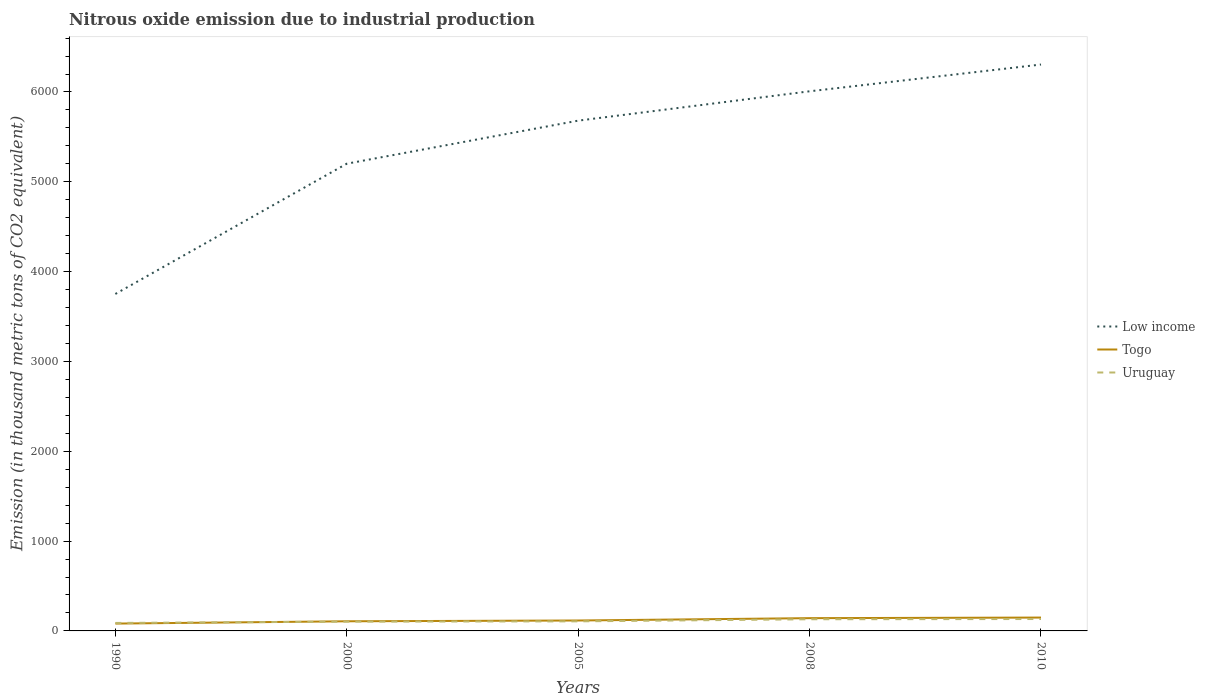How many different coloured lines are there?
Offer a terse response. 3. Across all years, what is the maximum amount of nitrous oxide emitted in Uruguay?
Offer a very short reply. 88.8. What is the total amount of nitrous oxide emitted in Low income in the graph?
Make the answer very short. -1929.5. What is the difference between the highest and the second highest amount of nitrous oxide emitted in Uruguay?
Your response must be concise. 43.7. Is the amount of nitrous oxide emitted in Togo strictly greater than the amount of nitrous oxide emitted in Uruguay over the years?
Give a very brief answer. No. How many lines are there?
Offer a terse response. 3. What is the difference between two consecutive major ticks on the Y-axis?
Provide a short and direct response. 1000. Does the graph contain any zero values?
Give a very brief answer. No. How many legend labels are there?
Give a very brief answer. 3. What is the title of the graph?
Provide a succinct answer. Nitrous oxide emission due to industrial production. Does "Comoros" appear as one of the legend labels in the graph?
Provide a short and direct response. No. What is the label or title of the X-axis?
Give a very brief answer. Years. What is the label or title of the Y-axis?
Your answer should be very brief. Emission (in thousand metric tons of CO2 equivalent). What is the Emission (in thousand metric tons of CO2 equivalent) of Low income in 1990?
Offer a terse response. 3751.3. What is the Emission (in thousand metric tons of CO2 equivalent) of Togo in 1990?
Your answer should be compact. 81.8. What is the Emission (in thousand metric tons of CO2 equivalent) in Uruguay in 1990?
Make the answer very short. 88.8. What is the Emission (in thousand metric tons of CO2 equivalent) of Low income in 2000?
Keep it short and to the point. 5201.5. What is the Emission (in thousand metric tons of CO2 equivalent) of Togo in 2000?
Ensure brevity in your answer.  107.3. What is the Emission (in thousand metric tons of CO2 equivalent) in Uruguay in 2000?
Provide a succinct answer. 103.4. What is the Emission (in thousand metric tons of CO2 equivalent) in Low income in 2005?
Offer a very short reply. 5680.8. What is the Emission (in thousand metric tons of CO2 equivalent) of Togo in 2005?
Provide a short and direct response. 116. What is the Emission (in thousand metric tons of CO2 equivalent) of Uruguay in 2005?
Provide a short and direct response. 106.6. What is the Emission (in thousand metric tons of CO2 equivalent) of Low income in 2008?
Offer a very short reply. 6007.5. What is the Emission (in thousand metric tons of CO2 equivalent) in Togo in 2008?
Your answer should be very brief. 142.1. What is the Emission (in thousand metric tons of CO2 equivalent) in Uruguay in 2008?
Offer a very short reply. 129.9. What is the Emission (in thousand metric tons of CO2 equivalent) of Low income in 2010?
Make the answer very short. 6305.5. What is the Emission (in thousand metric tons of CO2 equivalent) of Togo in 2010?
Make the answer very short. 148.8. What is the Emission (in thousand metric tons of CO2 equivalent) in Uruguay in 2010?
Make the answer very short. 132.5. Across all years, what is the maximum Emission (in thousand metric tons of CO2 equivalent) in Low income?
Ensure brevity in your answer.  6305.5. Across all years, what is the maximum Emission (in thousand metric tons of CO2 equivalent) in Togo?
Give a very brief answer. 148.8. Across all years, what is the maximum Emission (in thousand metric tons of CO2 equivalent) in Uruguay?
Ensure brevity in your answer.  132.5. Across all years, what is the minimum Emission (in thousand metric tons of CO2 equivalent) of Low income?
Provide a short and direct response. 3751.3. Across all years, what is the minimum Emission (in thousand metric tons of CO2 equivalent) in Togo?
Keep it short and to the point. 81.8. Across all years, what is the minimum Emission (in thousand metric tons of CO2 equivalent) of Uruguay?
Make the answer very short. 88.8. What is the total Emission (in thousand metric tons of CO2 equivalent) of Low income in the graph?
Your response must be concise. 2.69e+04. What is the total Emission (in thousand metric tons of CO2 equivalent) of Togo in the graph?
Make the answer very short. 596. What is the total Emission (in thousand metric tons of CO2 equivalent) in Uruguay in the graph?
Keep it short and to the point. 561.2. What is the difference between the Emission (in thousand metric tons of CO2 equivalent) of Low income in 1990 and that in 2000?
Your answer should be compact. -1450.2. What is the difference between the Emission (in thousand metric tons of CO2 equivalent) in Togo in 1990 and that in 2000?
Ensure brevity in your answer.  -25.5. What is the difference between the Emission (in thousand metric tons of CO2 equivalent) of Uruguay in 1990 and that in 2000?
Offer a very short reply. -14.6. What is the difference between the Emission (in thousand metric tons of CO2 equivalent) of Low income in 1990 and that in 2005?
Offer a very short reply. -1929.5. What is the difference between the Emission (in thousand metric tons of CO2 equivalent) of Togo in 1990 and that in 2005?
Your answer should be very brief. -34.2. What is the difference between the Emission (in thousand metric tons of CO2 equivalent) of Uruguay in 1990 and that in 2005?
Your answer should be very brief. -17.8. What is the difference between the Emission (in thousand metric tons of CO2 equivalent) of Low income in 1990 and that in 2008?
Provide a succinct answer. -2256.2. What is the difference between the Emission (in thousand metric tons of CO2 equivalent) of Togo in 1990 and that in 2008?
Ensure brevity in your answer.  -60.3. What is the difference between the Emission (in thousand metric tons of CO2 equivalent) of Uruguay in 1990 and that in 2008?
Your response must be concise. -41.1. What is the difference between the Emission (in thousand metric tons of CO2 equivalent) of Low income in 1990 and that in 2010?
Offer a terse response. -2554.2. What is the difference between the Emission (in thousand metric tons of CO2 equivalent) of Togo in 1990 and that in 2010?
Your response must be concise. -67. What is the difference between the Emission (in thousand metric tons of CO2 equivalent) in Uruguay in 1990 and that in 2010?
Provide a succinct answer. -43.7. What is the difference between the Emission (in thousand metric tons of CO2 equivalent) in Low income in 2000 and that in 2005?
Keep it short and to the point. -479.3. What is the difference between the Emission (in thousand metric tons of CO2 equivalent) in Uruguay in 2000 and that in 2005?
Offer a very short reply. -3.2. What is the difference between the Emission (in thousand metric tons of CO2 equivalent) of Low income in 2000 and that in 2008?
Make the answer very short. -806. What is the difference between the Emission (in thousand metric tons of CO2 equivalent) of Togo in 2000 and that in 2008?
Offer a terse response. -34.8. What is the difference between the Emission (in thousand metric tons of CO2 equivalent) in Uruguay in 2000 and that in 2008?
Make the answer very short. -26.5. What is the difference between the Emission (in thousand metric tons of CO2 equivalent) of Low income in 2000 and that in 2010?
Your answer should be compact. -1104. What is the difference between the Emission (in thousand metric tons of CO2 equivalent) of Togo in 2000 and that in 2010?
Provide a short and direct response. -41.5. What is the difference between the Emission (in thousand metric tons of CO2 equivalent) in Uruguay in 2000 and that in 2010?
Offer a very short reply. -29.1. What is the difference between the Emission (in thousand metric tons of CO2 equivalent) of Low income in 2005 and that in 2008?
Make the answer very short. -326.7. What is the difference between the Emission (in thousand metric tons of CO2 equivalent) in Togo in 2005 and that in 2008?
Your response must be concise. -26.1. What is the difference between the Emission (in thousand metric tons of CO2 equivalent) of Uruguay in 2005 and that in 2008?
Your answer should be very brief. -23.3. What is the difference between the Emission (in thousand metric tons of CO2 equivalent) of Low income in 2005 and that in 2010?
Provide a short and direct response. -624.7. What is the difference between the Emission (in thousand metric tons of CO2 equivalent) of Togo in 2005 and that in 2010?
Your answer should be very brief. -32.8. What is the difference between the Emission (in thousand metric tons of CO2 equivalent) of Uruguay in 2005 and that in 2010?
Your answer should be very brief. -25.9. What is the difference between the Emission (in thousand metric tons of CO2 equivalent) in Low income in 2008 and that in 2010?
Your answer should be very brief. -298. What is the difference between the Emission (in thousand metric tons of CO2 equivalent) of Togo in 2008 and that in 2010?
Your answer should be compact. -6.7. What is the difference between the Emission (in thousand metric tons of CO2 equivalent) in Low income in 1990 and the Emission (in thousand metric tons of CO2 equivalent) in Togo in 2000?
Give a very brief answer. 3644. What is the difference between the Emission (in thousand metric tons of CO2 equivalent) of Low income in 1990 and the Emission (in thousand metric tons of CO2 equivalent) of Uruguay in 2000?
Ensure brevity in your answer.  3647.9. What is the difference between the Emission (in thousand metric tons of CO2 equivalent) in Togo in 1990 and the Emission (in thousand metric tons of CO2 equivalent) in Uruguay in 2000?
Make the answer very short. -21.6. What is the difference between the Emission (in thousand metric tons of CO2 equivalent) of Low income in 1990 and the Emission (in thousand metric tons of CO2 equivalent) of Togo in 2005?
Keep it short and to the point. 3635.3. What is the difference between the Emission (in thousand metric tons of CO2 equivalent) in Low income in 1990 and the Emission (in thousand metric tons of CO2 equivalent) in Uruguay in 2005?
Offer a very short reply. 3644.7. What is the difference between the Emission (in thousand metric tons of CO2 equivalent) of Togo in 1990 and the Emission (in thousand metric tons of CO2 equivalent) of Uruguay in 2005?
Offer a terse response. -24.8. What is the difference between the Emission (in thousand metric tons of CO2 equivalent) of Low income in 1990 and the Emission (in thousand metric tons of CO2 equivalent) of Togo in 2008?
Provide a succinct answer. 3609.2. What is the difference between the Emission (in thousand metric tons of CO2 equivalent) of Low income in 1990 and the Emission (in thousand metric tons of CO2 equivalent) of Uruguay in 2008?
Your response must be concise. 3621.4. What is the difference between the Emission (in thousand metric tons of CO2 equivalent) in Togo in 1990 and the Emission (in thousand metric tons of CO2 equivalent) in Uruguay in 2008?
Offer a very short reply. -48.1. What is the difference between the Emission (in thousand metric tons of CO2 equivalent) in Low income in 1990 and the Emission (in thousand metric tons of CO2 equivalent) in Togo in 2010?
Provide a short and direct response. 3602.5. What is the difference between the Emission (in thousand metric tons of CO2 equivalent) in Low income in 1990 and the Emission (in thousand metric tons of CO2 equivalent) in Uruguay in 2010?
Make the answer very short. 3618.8. What is the difference between the Emission (in thousand metric tons of CO2 equivalent) of Togo in 1990 and the Emission (in thousand metric tons of CO2 equivalent) of Uruguay in 2010?
Ensure brevity in your answer.  -50.7. What is the difference between the Emission (in thousand metric tons of CO2 equivalent) in Low income in 2000 and the Emission (in thousand metric tons of CO2 equivalent) in Togo in 2005?
Ensure brevity in your answer.  5085.5. What is the difference between the Emission (in thousand metric tons of CO2 equivalent) of Low income in 2000 and the Emission (in thousand metric tons of CO2 equivalent) of Uruguay in 2005?
Make the answer very short. 5094.9. What is the difference between the Emission (in thousand metric tons of CO2 equivalent) in Low income in 2000 and the Emission (in thousand metric tons of CO2 equivalent) in Togo in 2008?
Provide a short and direct response. 5059.4. What is the difference between the Emission (in thousand metric tons of CO2 equivalent) of Low income in 2000 and the Emission (in thousand metric tons of CO2 equivalent) of Uruguay in 2008?
Give a very brief answer. 5071.6. What is the difference between the Emission (in thousand metric tons of CO2 equivalent) in Togo in 2000 and the Emission (in thousand metric tons of CO2 equivalent) in Uruguay in 2008?
Offer a terse response. -22.6. What is the difference between the Emission (in thousand metric tons of CO2 equivalent) of Low income in 2000 and the Emission (in thousand metric tons of CO2 equivalent) of Togo in 2010?
Give a very brief answer. 5052.7. What is the difference between the Emission (in thousand metric tons of CO2 equivalent) in Low income in 2000 and the Emission (in thousand metric tons of CO2 equivalent) in Uruguay in 2010?
Make the answer very short. 5069. What is the difference between the Emission (in thousand metric tons of CO2 equivalent) in Togo in 2000 and the Emission (in thousand metric tons of CO2 equivalent) in Uruguay in 2010?
Ensure brevity in your answer.  -25.2. What is the difference between the Emission (in thousand metric tons of CO2 equivalent) in Low income in 2005 and the Emission (in thousand metric tons of CO2 equivalent) in Togo in 2008?
Your answer should be very brief. 5538.7. What is the difference between the Emission (in thousand metric tons of CO2 equivalent) in Low income in 2005 and the Emission (in thousand metric tons of CO2 equivalent) in Uruguay in 2008?
Give a very brief answer. 5550.9. What is the difference between the Emission (in thousand metric tons of CO2 equivalent) of Low income in 2005 and the Emission (in thousand metric tons of CO2 equivalent) of Togo in 2010?
Your answer should be compact. 5532. What is the difference between the Emission (in thousand metric tons of CO2 equivalent) in Low income in 2005 and the Emission (in thousand metric tons of CO2 equivalent) in Uruguay in 2010?
Your answer should be very brief. 5548.3. What is the difference between the Emission (in thousand metric tons of CO2 equivalent) of Togo in 2005 and the Emission (in thousand metric tons of CO2 equivalent) of Uruguay in 2010?
Give a very brief answer. -16.5. What is the difference between the Emission (in thousand metric tons of CO2 equivalent) of Low income in 2008 and the Emission (in thousand metric tons of CO2 equivalent) of Togo in 2010?
Keep it short and to the point. 5858.7. What is the difference between the Emission (in thousand metric tons of CO2 equivalent) of Low income in 2008 and the Emission (in thousand metric tons of CO2 equivalent) of Uruguay in 2010?
Offer a very short reply. 5875. What is the average Emission (in thousand metric tons of CO2 equivalent) of Low income per year?
Your response must be concise. 5389.32. What is the average Emission (in thousand metric tons of CO2 equivalent) in Togo per year?
Give a very brief answer. 119.2. What is the average Emission (in thousand metric tons of CO2 equivalent) in Uruguay per year?
Make the answer very short. 112.24. In the year 1990, what is the difference between the Emission (in thousand metric tons of CO2 equivalent) of Low income and Emission (in thousand metric tons of CO2 equivalent) of Togo?
Give a very brief answer. 3669.5. In the year 1990, what is the difference between the Emission (in thousand metric tons of CO2 equivalent) in Low income and Emission (in thousand metric tons of CO2 equivalent) in Uruguay?
Give a very brief answer. 3662.5. In the year 1990, what is the difference between the Emission (in thousand metric tons of CO2 equivalent) in Togo and Emission (in thousand metric tons of CO2 equivalent) in Uruguay?
Your response must be concise. -7. In the year 2000, what is the difference between the Emission (in thousand metric tons of CO2 equivalent) in Low income and Emission (in thousand metric tons of CO2 equivalent) in Togo?
Keep it short and to the point. 5094.2. In the year 2000, what is the difference between the Emission (in thousand metric tons of CO2 equivalent) in Low income and Emission (in thousand metric tons of CO2 equivalent) in Uruguay?
Your answer should be compact. 5098.1. In the year 2005, what is the difference between the Emission (in thousand metric tons of CO2 equivalent) of Low income and Emission (in thousand metric tons of CO2 equivalent) of Togo?
Offer a terse response. 5564.8. In the year 2005, what is the difference between the Emission (in thousand metric tons of CO2 equivalent) of Low income and Emission (in thousand metric tons of CO2 equivalent) of Uruguay?
Provide a short and direct response. 5574.2. In the year 2005, what is the difference between the Emission (in thousand metric tons of CO2 equivalent) in Togo and Emission (in thousand metric tons of CO2 equivalent) in Uruguay?
Your answer should be compact. 9.4. In the year 2008, what is the difference between the Emission (in thousand metric tons of CO2 equivalent) in Low income and Emission (in thousand metric tons of CO2 equivalent) in Togo?
Provide a succinct answer. 5865.4. In the year 2008, what is the difference between the Emission (in thousand metric tons of CO2 equivalent) of Low income and Emission (in thousand metric tons of CO2 equivalent) of Uruguay?
Give a very brief answer. 5877.6. In the year 2010, what is the difference between the Emission (in thousand metric tons of CO2 equivalent) of Low income and Emission (in thousand metric tons of CO2 equivalent) of Togo?
Provide a succinct answer. 6156.7. In the year 2010, what is the difference between the Emission (in thousand metric tons of CO2 equivalent) of Low income and Emission (in thousand metric tons of CO2 equivalent) of Uruguay?
Give a very brief answer. 6173. What is the ratio of the Emission (in thousand metric tons of CO2 equivalent) in Low income in 1990 to that in 2000?
Ensure brevity in your answer.  0.72. What is the ratio of the Emission (in thousand metric tons of CO2 equivalent) in Togo in 1990 to that in 2000?
Your response must be concise. 0.76. What is the ratio of the Emission (in thousand metric tons of CO2 equivalent) of Uruguay in 1990 to that in 2000?
Your answer should be very brief. 0.86. What is the ratio of the Emission (in thousand metric tons of CO2 equivalent) in Low income in 1990 to that in 2005?
Offer a terse response. 0.66. What is the ratio of the Emission (in thousand metric tons of CO2 equivalent) of Togo in 1990 to that in 2005?
Provide a succinct answer. 0.71. What is the ratio of the Emission (in thousand metric tons of CO2 equivalent) of Uruguay in 1990 to that in 2005?
Offer a very short reply. 0.83. What is the ratio of the Emission (in thousand metric tons of CO2 equivalent) in Low income in 1990 to that in 2008?
Provide a succinct answer. 0.62. What is the ratio of the Emission (in thousand metric tons of CO2 equivalent) of Togo in 1990 to that in 2008?
Your answer should be very brief. 0.58. What is the ratio of the Emission (in thousand metric tons of CO2 equivalent) in Uruguay in 1990 to that in 2008?
Keep it short and to the point. 0.68. What is the ratio of the Emission (in thousand metric tons of CO2 equivalent) of Low income in 1990 to that in 2010?
Give a very brief answer. 0.59. What is the ratio of the Emission (in thousand metric tons of CO2 equivalent) in Togo in 1990 to that in 2010?
Your response must be concise. 0.55. What is the ratio of the Emission (in thousand metric tons of CO2 equivalent) of Uruguay in 1990 to that in 2010?
Keep it short and to the point. 0.67. What is the ratio of the Emission (in thousand metric tons of CO2 equivalent) of Low income in 2000 to that in 2005?
Offer a very short reply. 0.92. What is the ratio of the Emission (in thousand metric tons of CO2 equivalent) of Togo in 2000 to that in 2005?
Offer a terse response. 0.93. What is the ratio of the Emission (in thousand metric tons of CO2 equivalent) in Low income in 2000 to that in 2008?
Provide a short and direct response. 0.87. What is the ratio of the Emission (in thousand metric tons of CO2 equivalent) in Togo in 2000 to that in 2008?
Keep it short and to the point. 0.76. What is the ratio of the Emission (in thousand metric tons of CO2 equivalent) of Uruguay in 2000 to that in 2008?
Your response must be concise. 0.8. What is the ratio of the Emission (in thousand metric tons of CO2 equivalent) in Low income in 2000 to that in 2010?
Your answer should be very brief. 0.82. What is the ratio of the Emission (in thousand metric tons of CO2 equivalent) of Togo in 2000 to that in 2010?
Make the answer very short. 0.72. What is the ratio of the Emission (in thousand metric tons of CO2 equivalent) of Uruguay in 2000 to that in 2010?
Make the answer very short. 0.78. What is the ratio of the Emission (in thousand metric tons of CO2 equivalent) of Low income in 2005 to that in 2008?
Your response must be concise. 0.95. What is the ratio of the Emission (in thousand metric tons of CO2 equivalent) of Togo in 2005 to that in 2008?
Ensure brevity in your answer.  0.82. What is the ratio of the Emission (in thousand metric tons of CO2 equivalent) of Uruguay in 2005 to that in 2008?
Your response must be concise. 0.82. What is the ratio of the Emission (in thousand metric tons of CO2 equivalent) in Low income in 2005 to that in 2010?
Your answer should be compact. 0.9. What is the ratio of the Emission (in thousand metric tons of CO2 equivalent) of Togo in 2005 to that in 2010?
Provide a succinct answer. 0.78. What is the ratio of the Emission (in thousand metric tons of CO2 equivalent) in Uruguay in 2005 to that in 2010?
Give a very brief answer. 0.8. What is the ratio of the Emission (in thousand metric tons of CO2 equivalent) of Low income in 2008 to that in 2010?
Offer a terse response. 0.95. What is the ratio of the Emission (in thousand metric tons of CO2 equivalent) in Togo in 2008 to that in 2010?
Your answer should be very brief. 0.95. What is the ratio of the Emission (in thousand metric tons of CO2 equivalent) of Uruguay in 2008 to that in 2010?
Your answer should be compact. 0.98. What is the difference between the highest and the second highest Emission (in thousand metric tons of CO2 equivalent) in Low income?
Offer a very short reply. 298. What is the difference between the highest and the second highest Emission (in thousand metric tons of CO2 equivalent) of Togo?
Keep it short and to the point. 6.7. What is the difference between the highest and the lowest Emission (in thousand metric tons of CO2 equivalent) of Low income?
Your response must be concise. 2554.2. What is the difference between the highest and the lowest Emission (in thousand metric tons of CO2 equivalent) in Togo?
Your response must be concise. 67. What is the difference between the highest and the lowest Emission (in thousand metric tons of CO2 equivalent) of Uruguay?
Give a very brief answer. 43.7. 